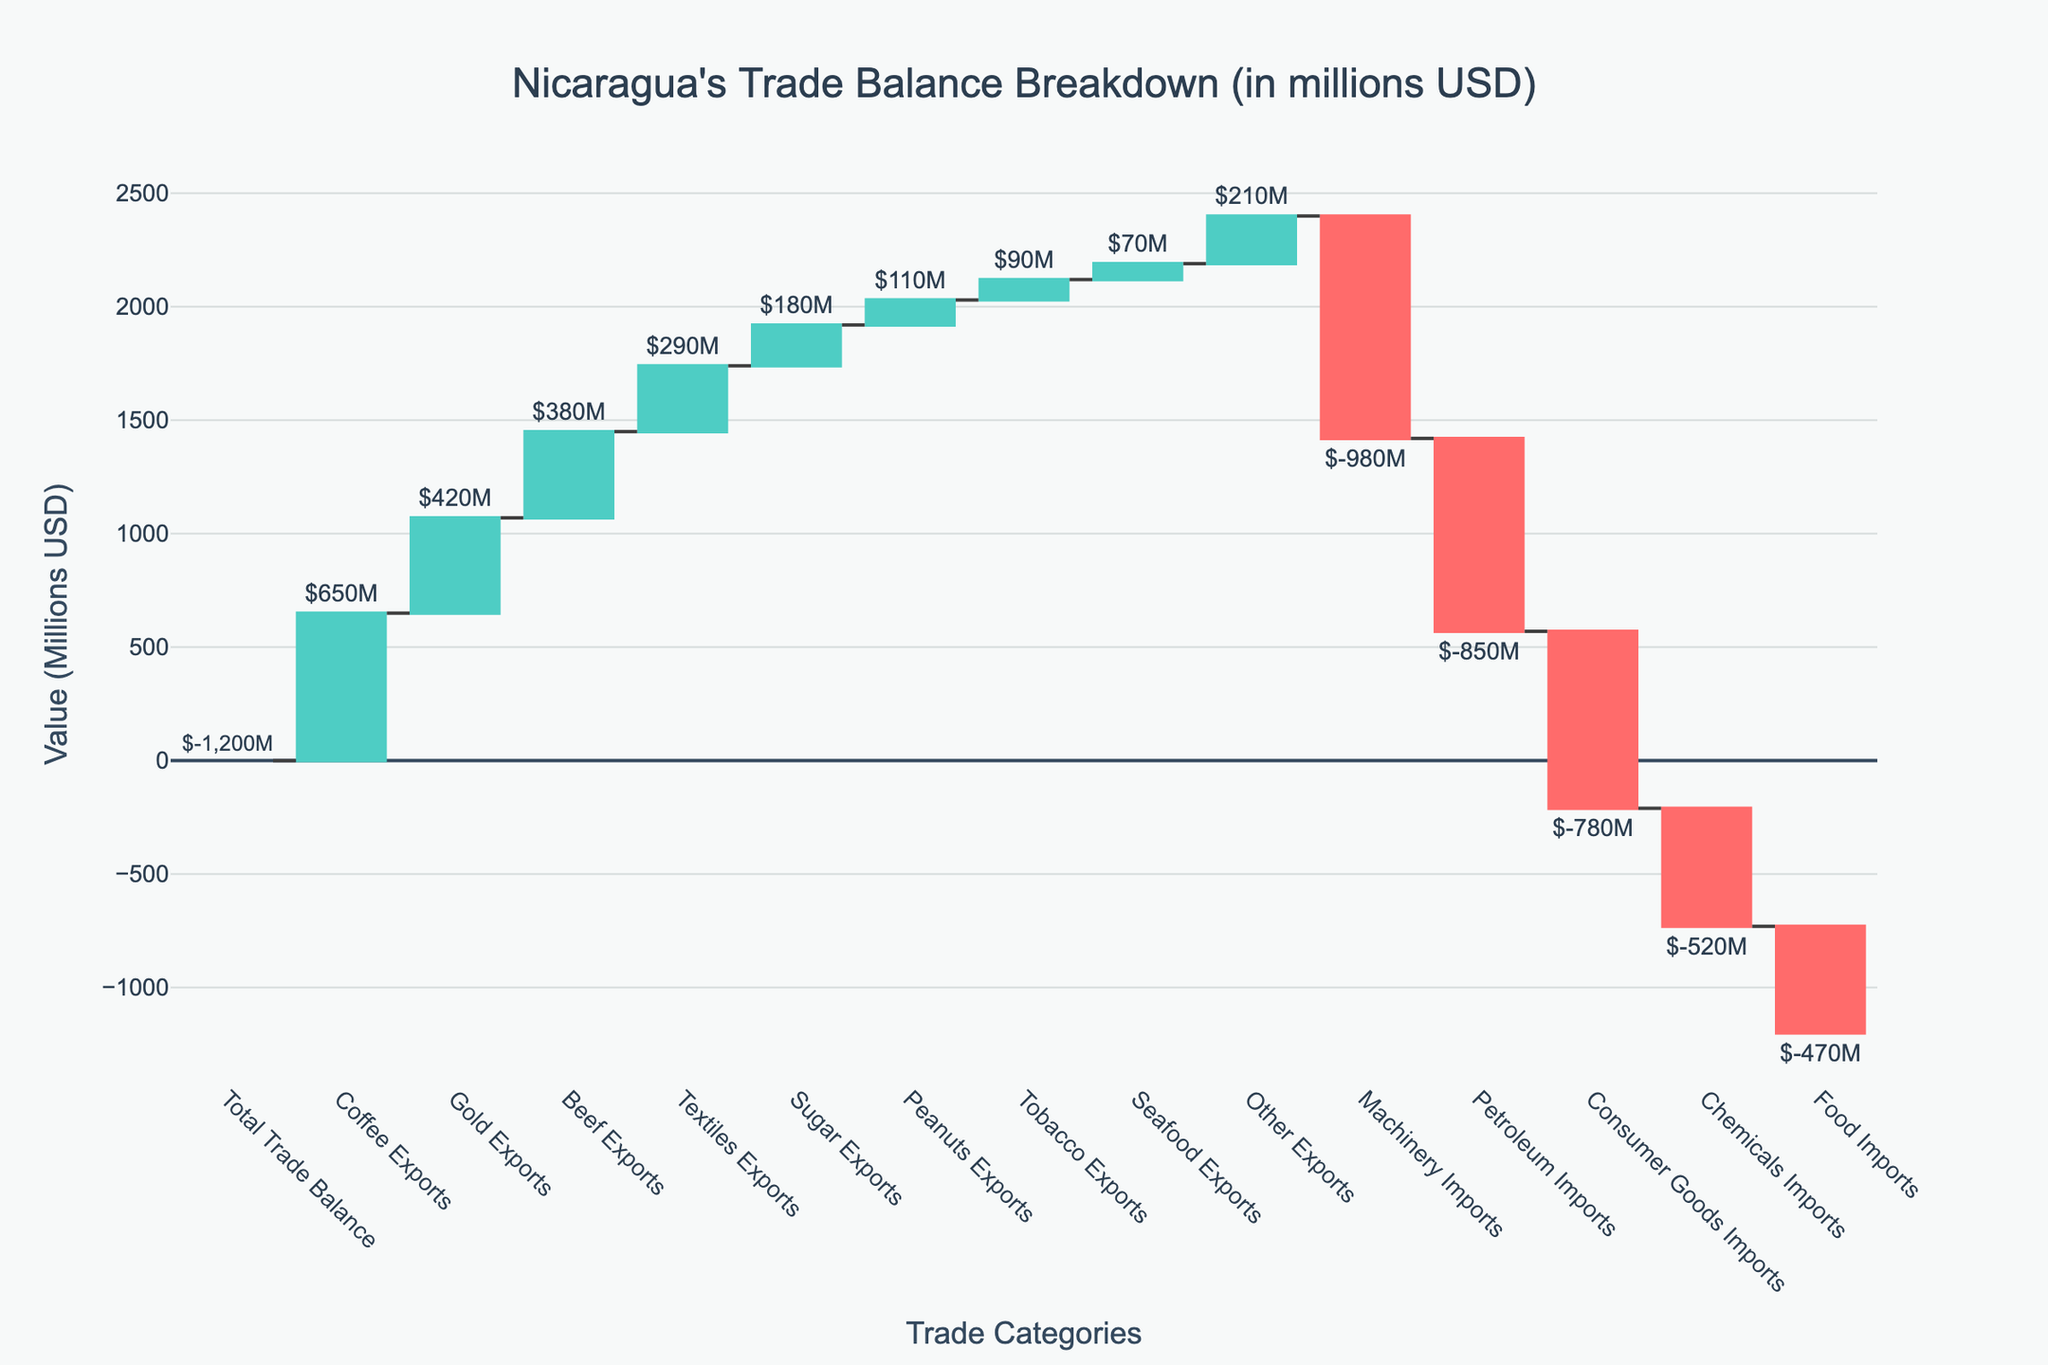What is the total trade balance? The figure's title clearly indicates it is showing Nicaragua's trade balance breakdown, and one of the bars is labeled "Total Trade Balance" with a value of -1200 (in millions USD).
Answer: -1200 What are the most significant exports and their values? By inspecting the figure, we can identify the bars representing "Coffee Exports", "Gold Exports", and "Beef Exports" which have values of 650, 420, and 380 (in millions USD), respectively.
Answer: Coffee: 650, Gold: 420, Beef: 380 How does machinery imports compare to petroleum imports? By looking at the figure, we see that "Machinery Imports" and "Petroleum Imports" are represented by two different bars, with values of -980 and -850 (in millions USD), respectively. "Machinery Imports" has a higher value (is more negative) compared to "Petroleum Imports".
Answer: Machinery: -980, Petroleum: -850 What's the difference between consumer goods imports and food imports? We need to identify the bars for "Consumer Goods Imports" and "Food Imports", which have values of -780 and -470 (in millions USD), respectively. Subtract the food imports value from the consumer goods imports value (-780 - (-470) = -310).
Answer: -310 Which export category has the smallest value and what is it? By checking all export bars, we find that "Seafood Exports" has the smallest value, which is 70 (in millions USD).
Answer: Seafood Exports: 70 What is the total value of all import categories? Sum the values of "Machinery Imports" (-980), "Petroleum Imports" (-850), "Consumer Goods Imports" (-780), "Chemicals Imports" (-520), and "Food Imports" (-470). The total value is -980 - 850 - 780 - 520 - 470 = -3600 (in millions USD).
Answer: -3600 Which import category shows the second-highest deficit? We first identify the import bars and their values: "Machinery Imports" (-980), "Petroleum Imports" (-850), "Consumer Goods Imports" (-780), "Chemicals Imports" (-520), and "Food Imports" (-470). The second-highest (less negative) value is "Petroleum Imports" at -850.
Answer: Petroleum Imports: -850 Among the exports, which category has a higher value, sugar or peanuts? Locate the bars for "Sugar Exports" and "Peanuts Exports," which have values of 180 and 110 (in millions USD), respectively. "Sugar Exports" has the higher value.
Answer: Sugar Exports: 180, Peanuts Exports: 110 What's the combined value of Coffee, Gold, and Beef exports? Add the values of "Coffee Exports" (650), "Gold Exports" (420), and "Beef Exports" (380). The combined value is 650 + 420 + 380 = 1450 (in millions USD).
Answer: 1450 What proportion of total exports is made up by the Coffee export category? The value of "Coffee Exports" is 650. To find the proportion, we sum up all export categories: 650 (Coffee) + 420 (Gold) + 380 (Beef) + 290 (Textiles) + 180 (Sugar) + 110 (Peanuts) + 90 (Tobacco) + 70 (Seafood) + 210 (Other) = 2400. The proportion is 650 / 2400 ≈ 0.2708, or approximately 27%.
Answer: 27% 